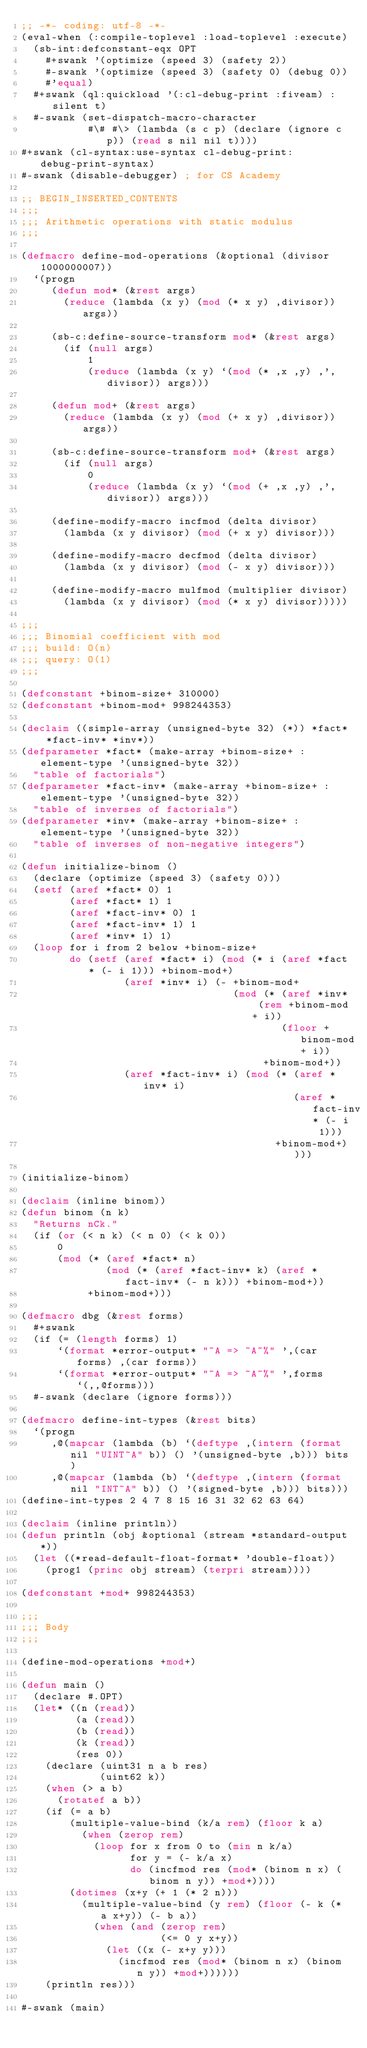<code> <loc_0><loc_0><loc_500><loc_500><_Lisp_>;; -*- coding: utf-8 -*-
(eval-when (:compile-toplevel :load-toplevel :execute)
  (sb-int:defconstant-eqx OPT
    #+swank '(optimize (speed 3) (safety 2))
    #-swank '(optimize (speed 3) (safety 0) (debug 0))
    #'equal)
  #+swank (ql:quickload '(:cl-debug-print :fiveam) :silent t)
  #-swank (set-dispatch-macro-character
           #\# #\> (lambda (s c p) (declare (ignore c p)) (read s nil nil t))))
#+swank (cl-syntax:use-syntax cl-debug-print:debug-print-syntax)
#-swank (disable-debugger) ; for CS Academy

;; BEGIN_INSERTED_CONTENTS
;;;
;;; Arithmetic operations with static modulus
;;;

(defmacro define-mod-operations (&optional (divisor 1000000007))
  `(progn
     (defun mod* (&rest args)
       (reduce (lambda (x y) (mod (* x y) ,divisor)) args))

     (sb-c:define-source-transform mod* (&rest args)
       (if (null args)
           1
           (reduce (lambda (x y) `(mod (* ,x ,y) ,',divisor)) args)))

     (defun mod+ (&rest args)
       (reduce (lambda (x y) (mod (+ x y) ,divisor)) args))

     (sb-c:define-source-transform mod+ (&rest args)
       (if (null args)
           0
           (reduce (lambda (x y) `(mod (+ ,x ,y) ,',divisor)) args)))

     (define-modify-macro incfmod (delta divisor)
       (lambda (x y divisor) (mod (+ x y) divisor)))

     (define-modify-macro decfmod (delta divisor)
       (lambda (x y divisor) (mod (- x y) divisor)))

     (define-modify-macro mulfmod (multiplier divisor)
       (lambda (x y divisor) (mod (* x y) divisor)))))

;;;
;;; Binomial coefficient with mod
;;; build: O(n)
;;; query: O(1)
;;;

(defconstant +binom-size+ 310000)
(defconstant +binom-mod+ 998244353)

(declaim ((simple-array (unsigned-byte 32) (*)) *fact* *fact-inv* *inv*))
(defparameter *fact* (make-array +binom-size+ :element-type '(unsigned-byte 32))
  "table of factorials")
(defparameter *fact-inv* (make-array +binom-size+ :element-type '(unsigned-byte 32))
  "table of inverses of factorials")
(defparameter *inv* (make-array +binom-size+ :element-type '(unsigned-byte 32))
  "table of inverses of non-negative integers")

(defun initialize-binom ()
  (declare (optimize (speed 3) (safety 0)))
  (setf (aref *fact* 0) 1
        (aref *fact* 1) 1
        (aref *fact-inv* 0) 1
        (aref *fact-inv* 1) 1
        (aref *inv* 1) 1)
  (loop for i from 2 below +binom-size+
        do (setf (aref *fact* i) (mod (* i (aref *fact* (- i 1))) +binom-mod+)
                 (aref *inv* i) (- +binom-mod+
                                   (mod (* (aref *inv* (rem +binom-mod+ i))
                                           (floor +binom-mod+ i))
                                        +binom-mod+))
                 (aref *fact-inv* i) (mod (* (aref *inv* i)
                                             (aref *fact-inv* (- i 1)))
                                          +binom-mod+))))

(initialize-binom)

(declaim (inline binom))
(defun binom (n k)
  "Returns nCk."
  (if (or (< n k) (< n 0) (< k 0))
      0
      (mod (* (aref *fact* n)
              (mod (* (aref *fact-inv* k) (aref *fact-inv* (- n k))) +binom-mod+))
           +binom-mod+)))

(defmacro dbg (&rest forms)
  #+swank
  (if (= (length forms) 1)
      `(format *error-output* "~A => ~A~%" ',(car forms) ,(car forms))
      `(format *error-output* "~A => ~A~%" ',forms `(,,@forms)))
  #-swank (declare (ignore forms)))

(defmacro define-int-types (&rest bits)
  `(progn
     ,@(mapcar (lambda (b) `(deftype ,(intern (format nil "UINT~A" b)) () '(unsigned-byte ,b))) bits)
     ,@(mapcar (lambda (b) `(deftype ,(intern (format nil "INT~A" b)) () '(signed-byte ,b))) bits)))
(define-int-types 2 4 7 8 15 16 31 32 62 63 64)

(declaim (inline println))
(defun println (obj &optional (stream *standard-output*))
  (let ((*read-default-float-format* 'double-float))
    (prog1 (princ obj stream) (terpri stream))))

(defconstant +mod+ 998244353)

;;;
;;; Body
;;;

(define-mod-operations +mod+)

(defun main ()
  (declare #.OPT)
  (let* ((n (read))
         (a (read))
         (b (read))
         (k (read))
         (res 0))
    (declare (uint31 n a b res)
             (uint62 k))
    (when (> a b)
      (rotatef a b))
    (if (= a b)
        (multiple-value-bind (k/a rem) (floor k a)
          (when (zerop rem)
            (loop for x from 0 to (min n k/a)
                  for y = (- k/a x)
                  do (incfmod res (mod* (binom n x) (binom n y)) +mod+))))
        (dotimes (x+y (+ 1 (* 2 n)))
          (multiple-value-bind (y rem) (floor (- k (* a x+y)) (- b a))
            (when (and (zerop rem)
                       (<= 0 y x+y))
              (let ((x (- x+y y)))
                (incfmod res (mod* (binom n x) (binom n y)) +mod+))))))
    (println res)))

#-swank (main)
</code> 